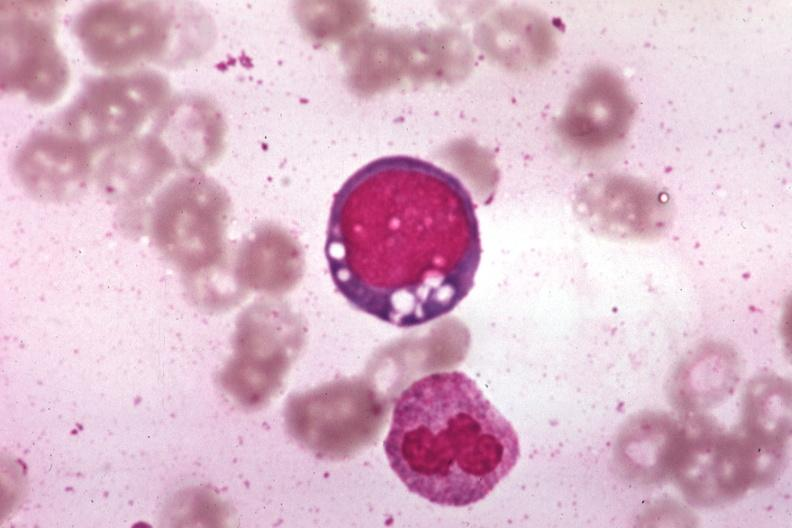what vacuolated erythroblast source unknown?
Answer the question using a single word or phrase. Wrights 